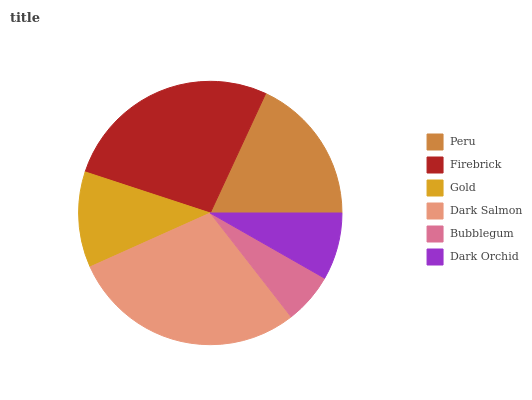Is Bubblegum the minimum?
Answer yes or no. Yes. Is Dark Salmon the maximum?
Answer yes or no. Yes. Is Firebrick the minimum?
Answer yes or no. No. Is Firebrick the maximum?
Answer yes or no. No. Is Firebrick greater than Peru?
Answer yes or no. Yes. Is Peru less than Firebrick?
Answer yes or no. Yes. Is Peru greater than Firebrick?
Answer yes or no. No. Is Firebrick less than Peru?
Answer yes or no. No. Is Peru the high median?
Answer yes or no. Yes. Is Gold the low median?
Answer yes or no. Yes. Is Gold the high median?
Answer yes or no. No. Is Peru the low median?
Answer yes or no. No. 